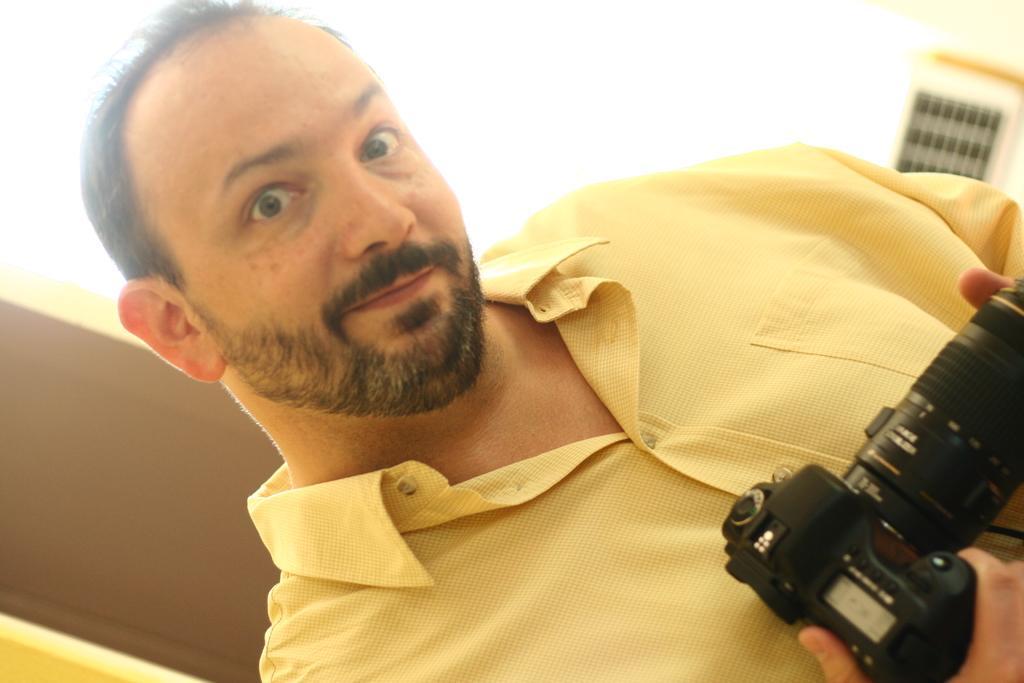How would you summarize this image in a sentence or two? In this image, we can see a person holding a camera. In the background, there is a door and a wall. 